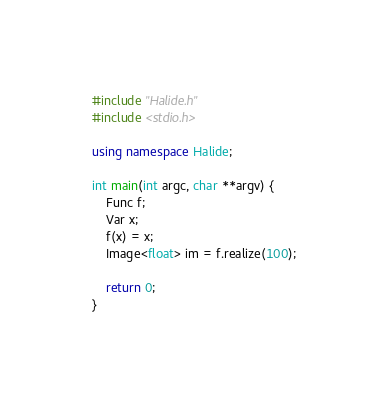<code> <loc_0><loc_0><loc_500><loc_500><_C++_>#include "Halide.h"
#include <stdio.h>

using namespace Halide;

int main(int argc, char **argv) {
    Func f;
    Var x;
    f(x) = x;
    Image<float> im = f.realize(100);

    return 0;
}
</code> 